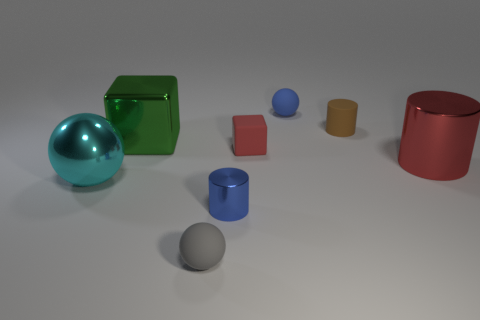Add 2 rubber balls. How many objects exist? 10 Subtract all cylinders. How many objects are left? 5 Subtract 0 purple balls. How many objects are left? 8 Subtract all red things. Subtract all tiny gray spheres. How many objects are left? 5 Add 1 large red cylinders. How many large red cylinders are left? 2 Add 7 purple cylinders. How many purple cylinders exist? 7 